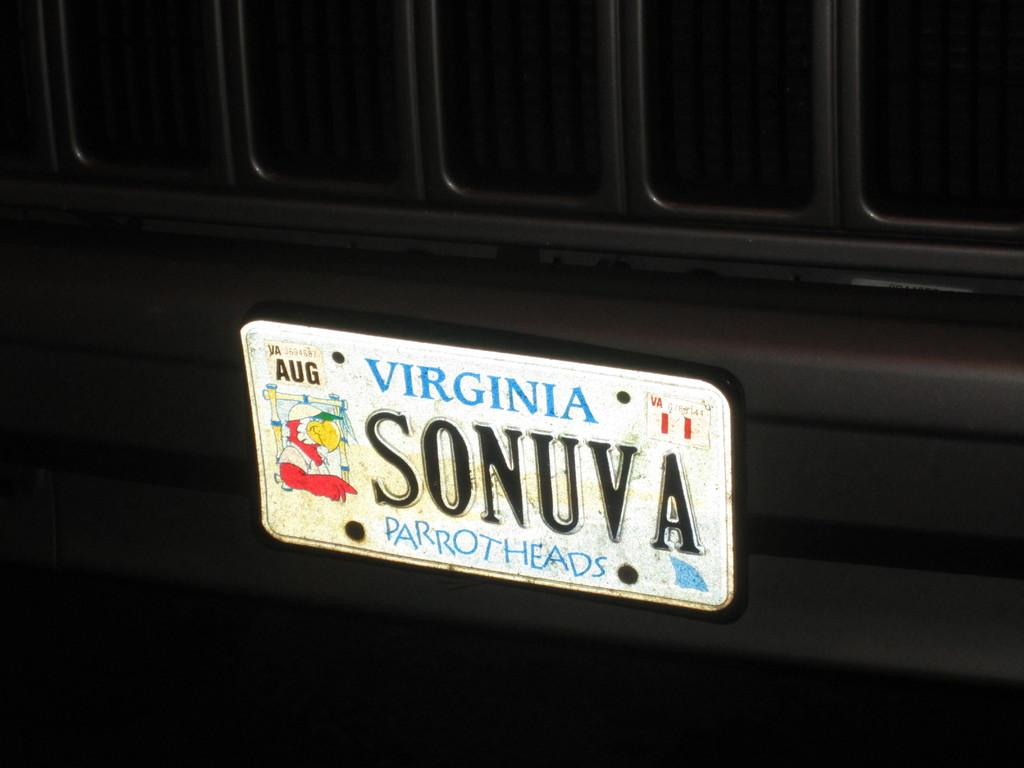<image>
Offer a succinct explanation of the picture presented. A Virginia license plate is marked with the letters SONUVA. 